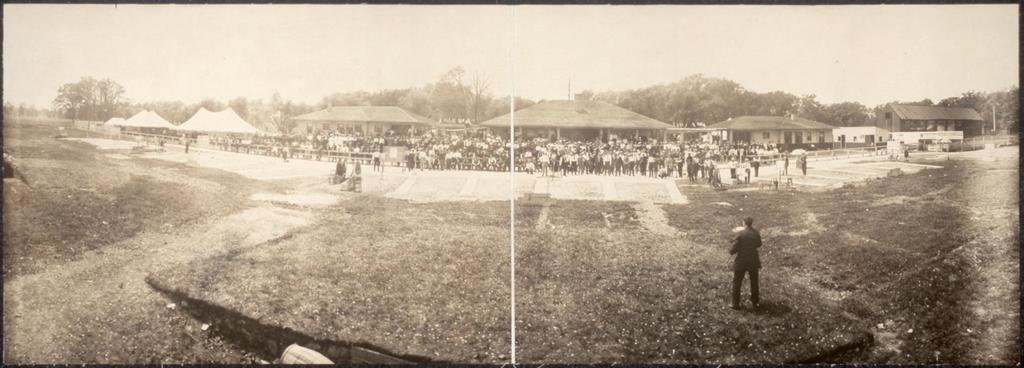Describe this image in one or two sentences. In this image I can see people are standing on the ground. In the background I can see the trees and the sky. This picture is black and white in color. 